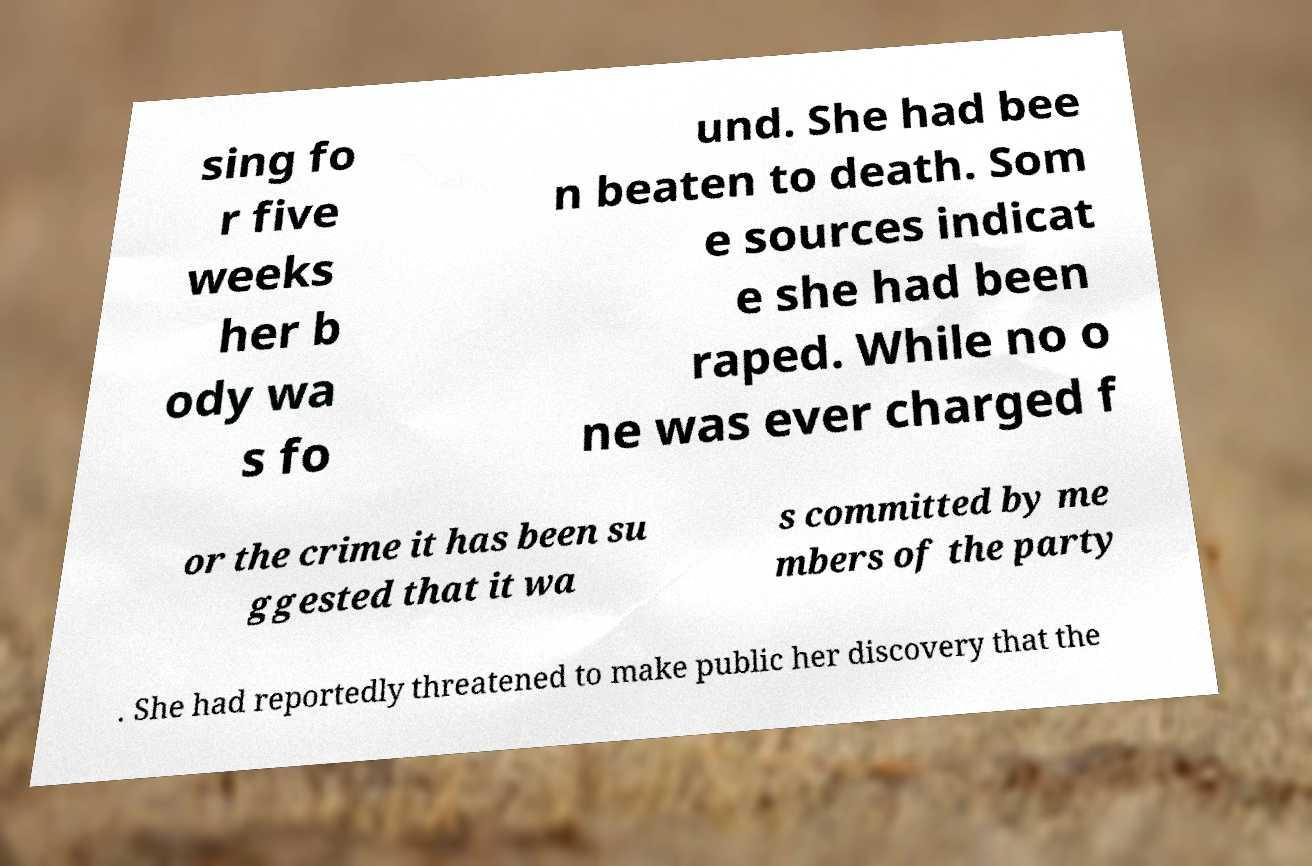Could you extract and type out the text from this image? sing fo r five weeks her b ody wa s fo und. She had bee n beaten to death. Som e sources indicat e she had been raped. While no o ne was ever charged f or the crime it has been su ggested that it wa s committed by me mbers of the party . She had reportedly threatened to make public her discovery that the 